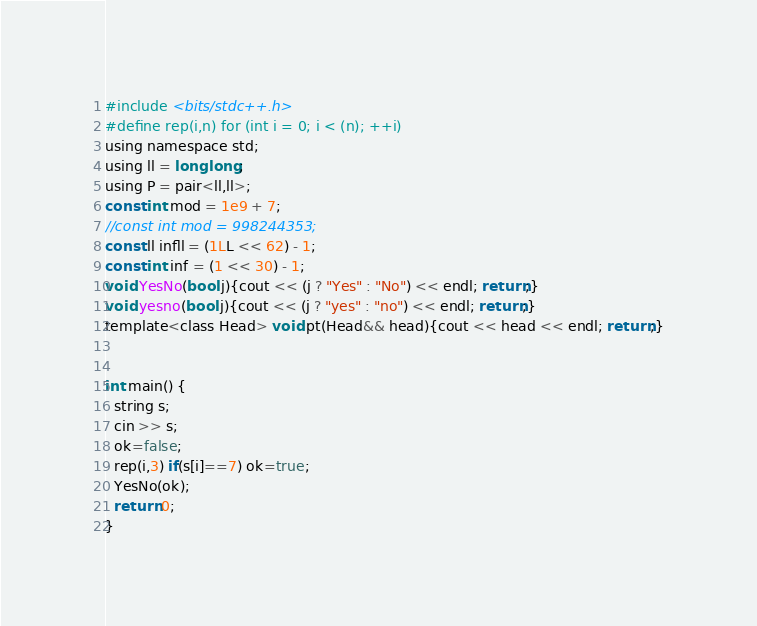Convert code to text. <code><loc_0><loc_0><loc_500><loc_500><_C_>#include <bits/stdc++.h>
#define rep(i,n) for (int i = 0; i < (n); ++i)
using namespace std;
using ll = long long;
using P = pair<ll,ll>;
const int mod = 1e9 + 7;
//const int mod = 998244353;
const ll infll = (1LL << 62) - 1;
const int inf = (1 << 30) - 1;
void YesNo(bool j){cout << (j ? "Yes" : "No") << endl; return;}
void yesno(bool j){cout << (j ? "yes" : "no") << endl; return;}
template<class Head> void pt(Head&& head){cout << head << endl; return;}


int main() {
  string s;
  cin >> s;
  ok=false;
  rep(i,3) if(s[i]==7) ok=true;
  YesNo(ok);
  return 0;
}</code> 